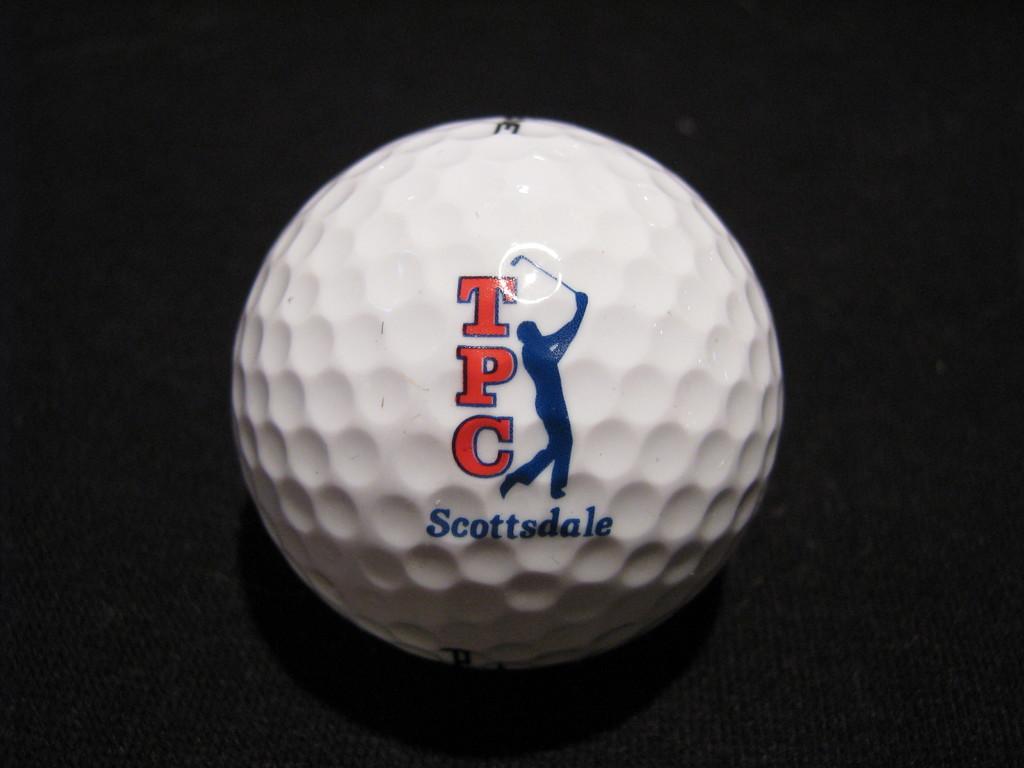Where was this tournament?
Offer a terse response. Scottsdale. What tournament is this ball from?
Keep it short and to the point. Tpc scottsdale. 